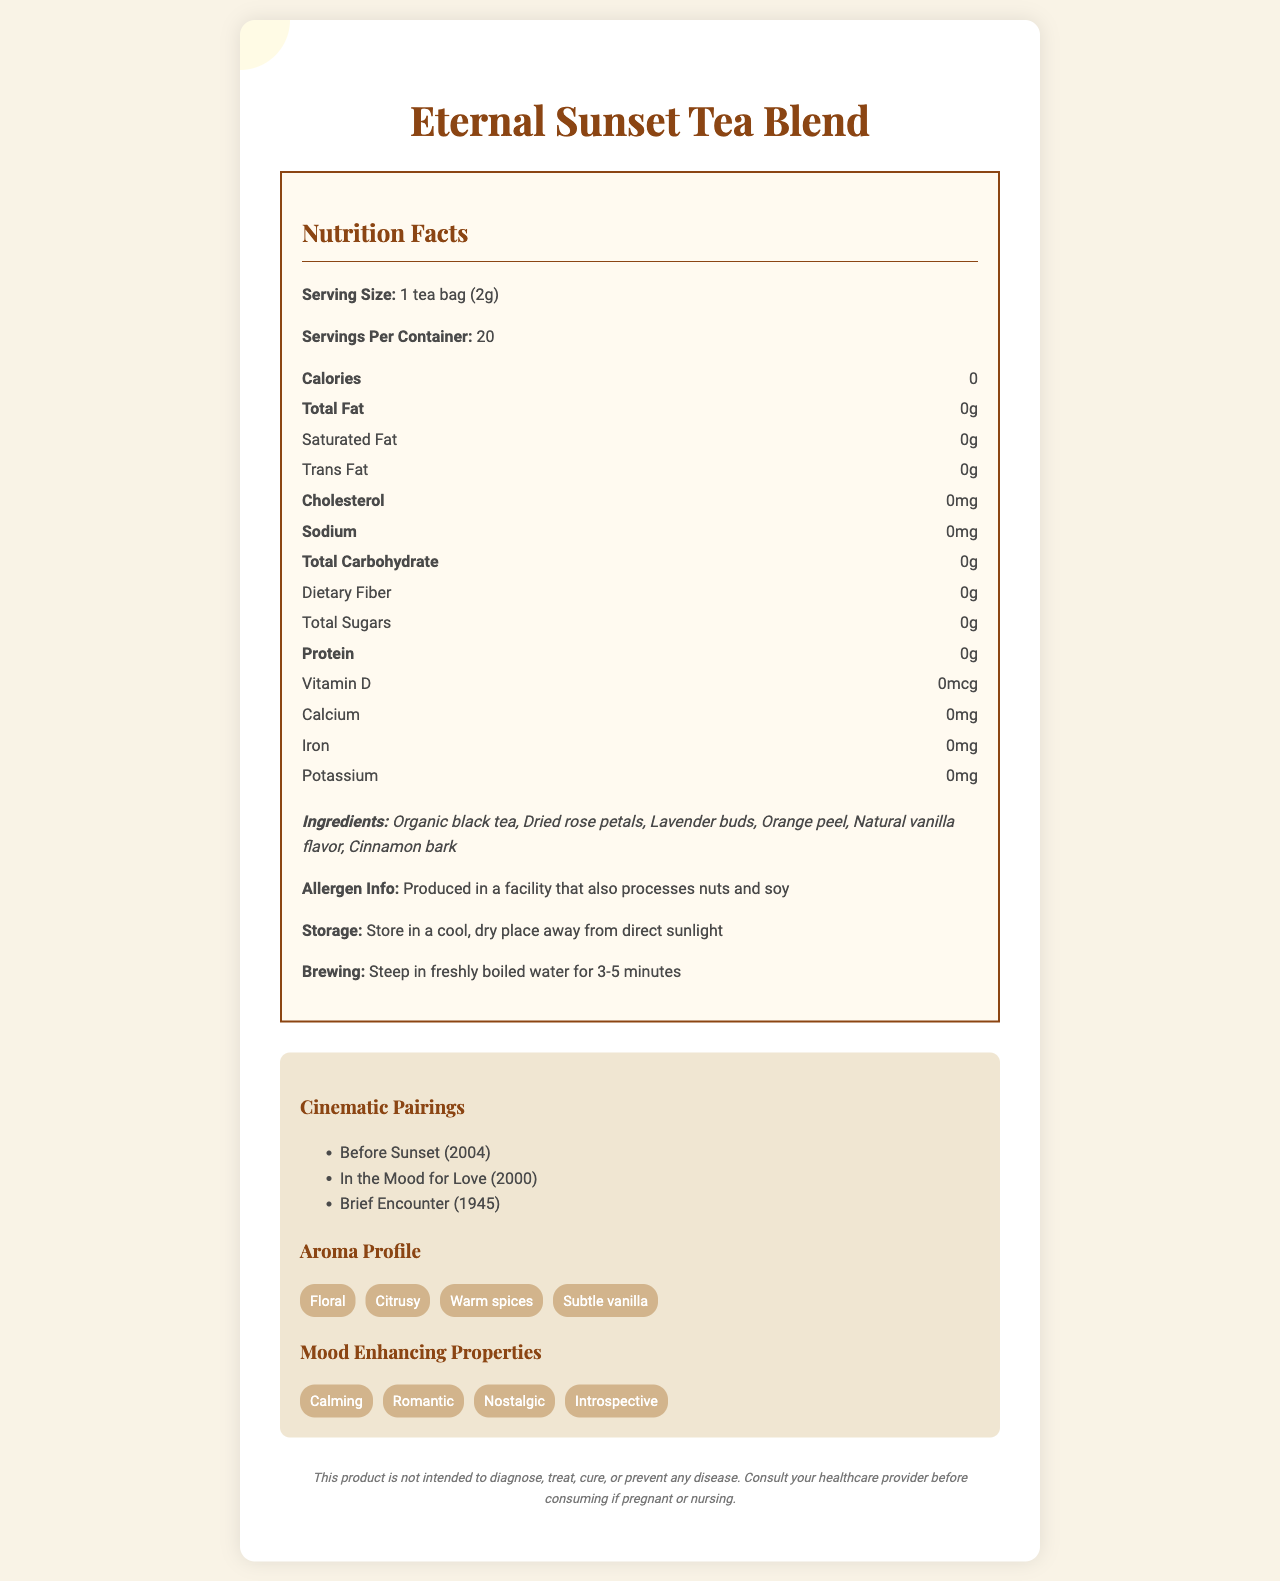what is the serving size of the Eternal Sunset Tea Blend? The serving size is explicitly mentioned as "1 tea bag (2g)" in the nutrition label.
Answer: 1 tea bag (2g) how many calories are in one serving of this tea blend? The nutrition label clearly states that there are 0 calories per serving.
Answer: 0 what are the main ingredients of the Eternal Sunset Tea Blend? The ingredients are listed under the "Ingredients" section.
Answer: Organic black tea, Dried rose petals, Lavender buds, Orange peel, Natural vanilla flavor, Cinnamon bark how should you store the Eternal Sunset Tea Blend? The storage instructions specify to store the product in a cool, dry place away from direct sunlight.
Answer: Store in a cool, dry place away from direct sunlight Which movie inspired the description of the Eternal Sunset Tea Blend? The product description mentions that the tea blend is inspired by the movie "Before Sunset".
Answer: Before Sunset what is the aroma profile of this tea blend? The "Aroma Profile" section lists these specific aromas.
Answer: Floral, Citrusy, Warm spices, Subtle vanilla what are the mood-enhancing properties of this tea blend? The "Mood Enhancing Properties" section includes these attributes.
Answer: Calming, Romantic, Nostalgic, Introspective which of the following movies is NOT listed as a cinematic pairing? A. Before Sunset B. Before Sunrise C. In the Mood for Love D. Brief Encounter "Before Sunrise" is not listed among the cinematic pairings.
Answer: B. Before Sunrise how long should you steep the tea bag in freshly boiled water? A. 1-2 minutes B. 3-5 minutes C. 5-7 minutes D. 7-10 minutes The brewing instructions mention steeping the tea bag for 3-5 minutes.
Answer: B. 3-5 minutes is there any protein in the Eternal Sunset Tea Blend? The nutrition facts indicate 0g of protein per serving.
Answer: No is the packaging of this tea blend sustainable? The sustainability information mentions biodegradable tea bags and recyclable packaging.
Answer: Yes what are the cinematic pairings recommended for this tea? These movies are listed under the "Cinematic Pairings" section.
Answer: Before Sunset (2004), In the Mood for Love (2000), Brief Encounter (1945) does this tea blend contain any added sugars? The nutrition facts state there are 0g of total sugars.
Answer: No is it safe to consume this tea if you are pregnant? The disclaimer advises consulting a healthcare provider if pregnant or nursing.
Answer: Consult your healthcare provider before consuming if pregnant or nursing which essential nutrients (Vitamin D, Calcium, Iron, Potassium) are present in this tea blend? The nutrition facts show 0mcg of Vitamin D, 0mg of Calcium, 0mg of Iron, and 0mg of Potassium.
Answer: None can the allergen information be determined from the document? The allergen info states that the product is produced in a facility that also processes nuts and soy.
Answer: Yes what is the main idea of the document? The document covers various aspects of the tea blend, including nutritional facts, ingredients, storage, brewing instructions, aroma profile, mood-enhancing properties, and cinematic pairings, offering a blend that reflects a romantic and nostalgic experience.
Answer: The document provides comprehensive information about the Eternal Sunset Tea Blend, highlighting its calorie-free nature, aromatic ingredients, romantic inspiration from the movie "Before Sunset", and additional benefits like sustainability and mood-enhancing properties. what is the main goal of the Eternal Sunset Tea Blend's flavor profile? The product description specifies this aim, drawing inspiration from the movie "Before Sunset" and describing the sensory experience.
Answer: To evoke the ambiance of a beloved romantic drama, capturing the essence of a Parisian summer evening with a balance of black tea, floral notes, and warm spices. what does the document indicate about the tea's ability to treat or cure diseases? The disclaimer clearly states that the product is not intended for medical purposes.
Answer: This product is not intended to diagnose, treat, cure, or prevent any disease. 